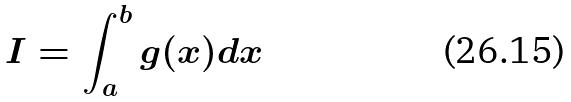<formula> <loc_0><loc_0><loc_500><loc_500>I = \int _ { a } ^ { b } g ( x ) d x</formula> 